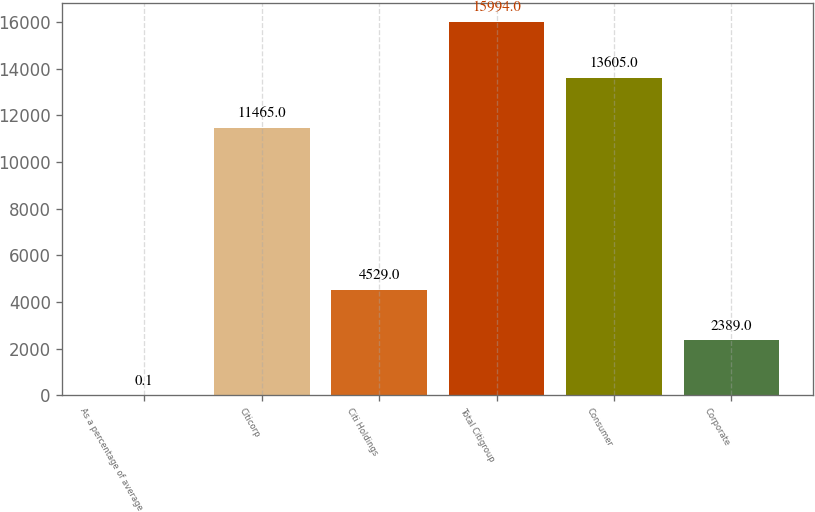Convert chart. <chart><loc_0><loc_0><loc_500><loc_500><bar_chart><fcel>As a percentage of average<fcel>Citicorp<fcel>Citi Holdings<fcel>Total Citigroup<fcel>Consumer<fcel>Corporate<nl><fcel>0.1<fcel>11465<fcel>4529<fcel>15994<fcel>13605<fcel>2389<nl></chart> 